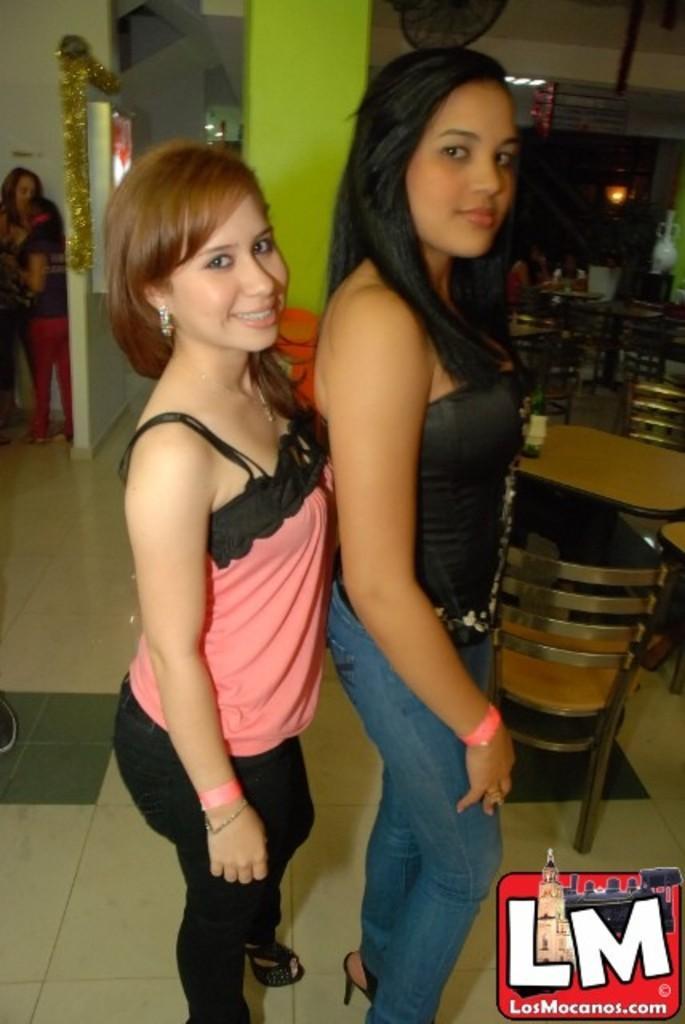How would you summarize this image in a sentence or two? In this image there are people and wall in the left corner. There are two persons in the foreground. There is some text, tables , chairs in the right corner. There is a wall in the background. There is a light hanging on roof at the top. And there is a floor at the bottom. 